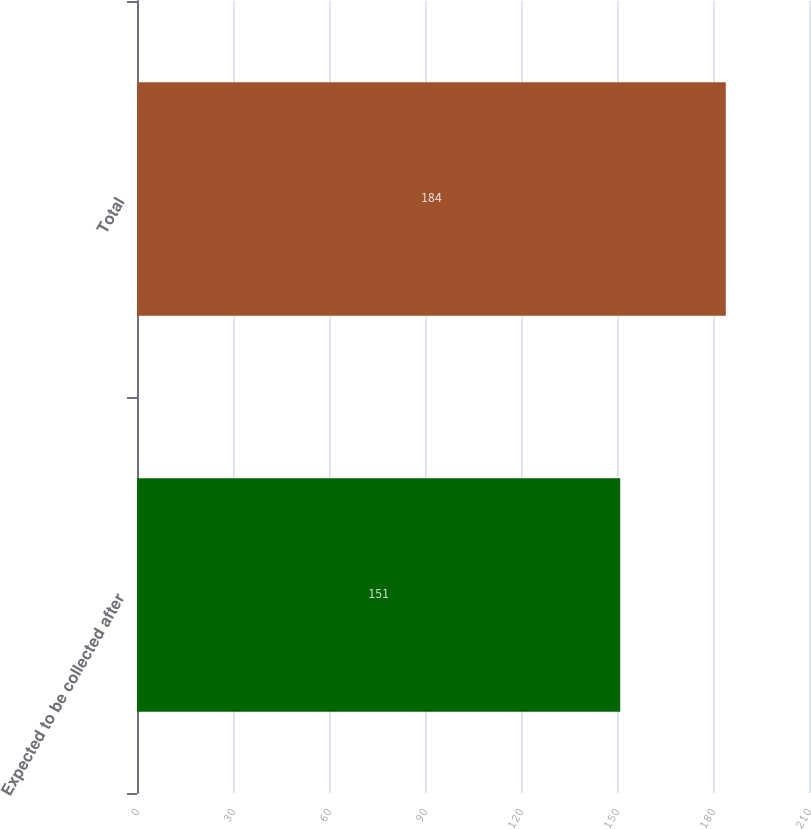<chart> <loc_0><loc_0><loc_500><loc_500><bar_chart><fcel>Expected to be collected after<fcel>Total<nl><fcel>151<fcel>184<nl></chart> 